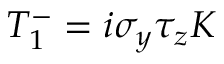<formula> <loc_0><loc_0><loc_500><loc_500>T _ { 1 } ^ { - } = i \sigma _ { y } \tau _ { z } K</formula> 